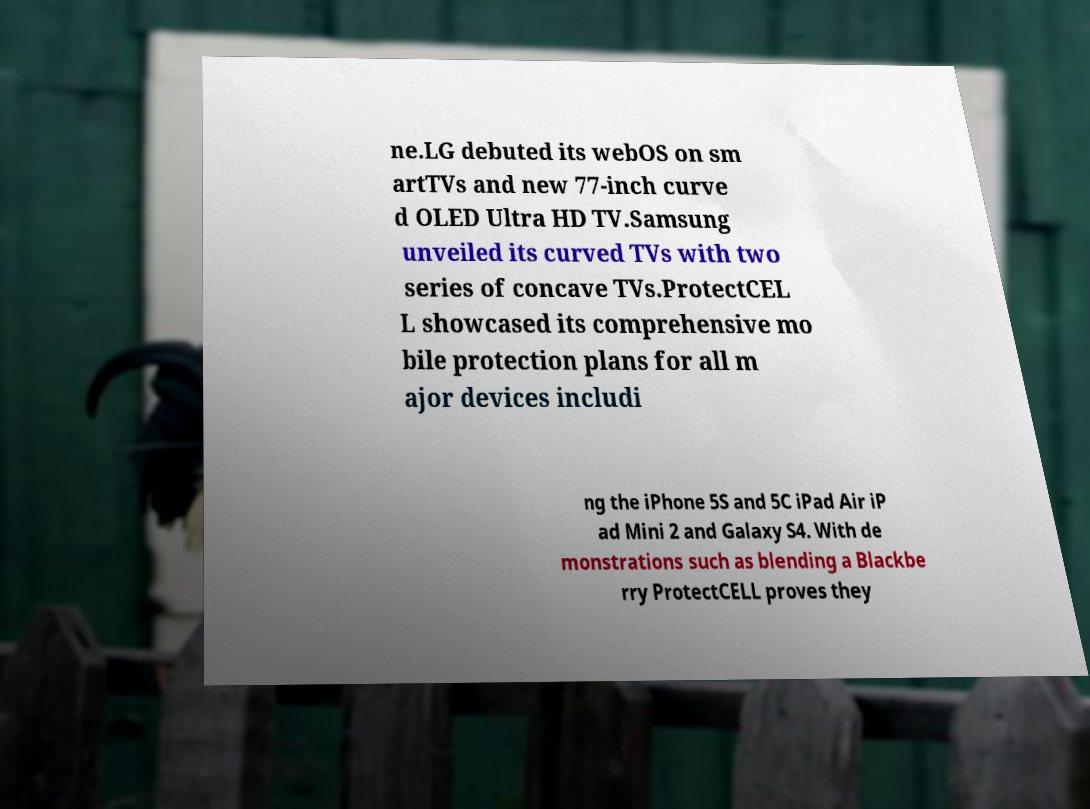What messages or text are displayed in this image? I need them in a readable, typed format. ne.LG debuted its webOS on sm artTVs and new 77-inch curve d OLED Ultra HD TV.Samsung unveiled its curved TVs with two series of concave TVs.ProtectCEL L showcased its comprehensive mo bile protection plans for all m ajor devices includi ng the iPhone 5S and 5C iPad Air iP ad Mini 2 and Galaxy S4. With de monstrations such as blending a Blackbe rry ProtectCELL proves they 